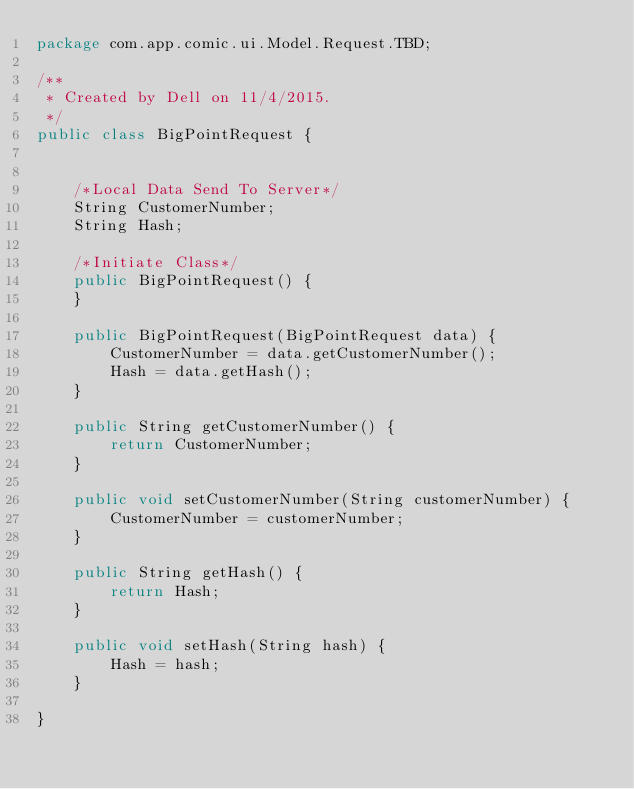Convert code to text. <code><loc_0><loc_0><loc_500><loc_500><_Java_>package com.app.comic.ui.Model.Request.TBD;

/**
 * Created by Dell on 11/4/2015.
 */
public class BigPointRequest {


    /*Local Data Send To Server*/
    String CustomerNumber;
    String Hash;

    /*Initiate Class*/
    public BigPointRequest() {
    }

    public BigPointRequest(BigPointRequest data) {
        CustomerNumber = data.getCustomerNumber();
        Hash = data.getHash();
    }

    public String getCustomerNumber() {
        return CustomerNumber;
    }

    public void setCustomerNumber(String customerNumber) {
        CustomerNumber = customerNumber;
    }

    public String getHash() {
        return Hash;
    }

    public void setHash(String hash) {
        Hash = hash;
    }

}
</code> 